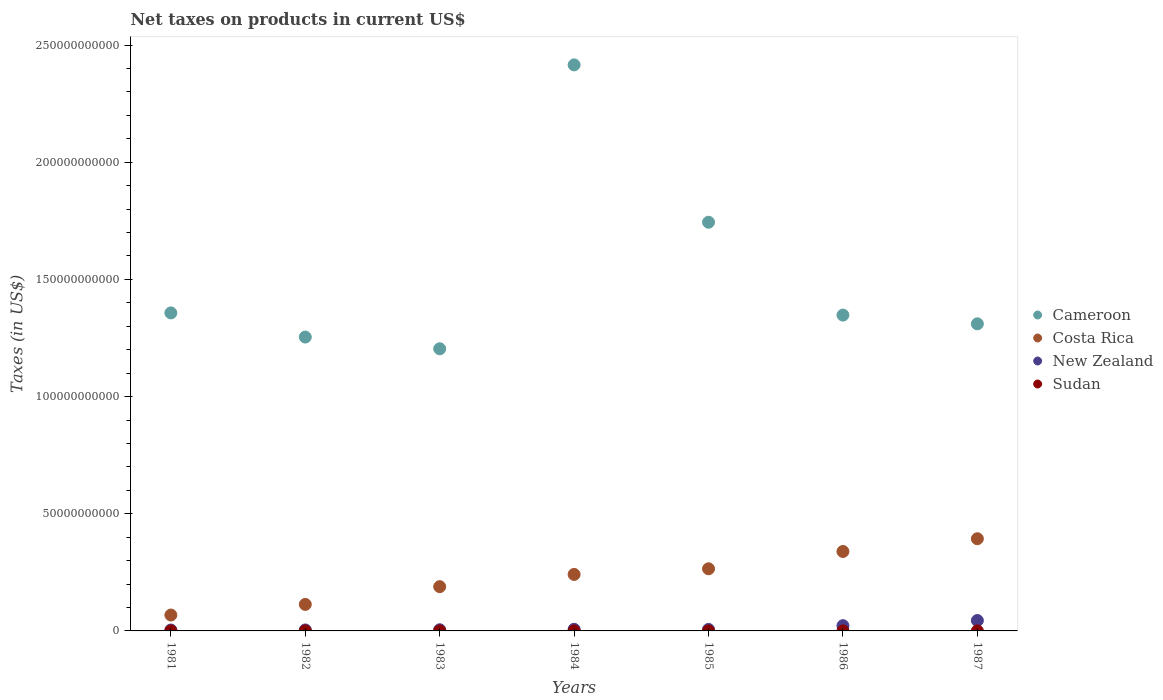Is the number of dotlines equal to the number of legend labels?
Provide a short and direct response. Yes. What is the net taxes on products in New Zealand in 1981?
Your response must be concise. 3.92e+08. Across all years, what is the maximum net taxes on products in Costa Rica?
Offer a terse response. 3.93e+1. Across all years, what is the minimum net taxes on products in Cameroon?
Provide a succinct answer. 1.20e+11. In which year was the net taxes on products in Costa Rica maximum?
Your answer should be very brief. 1987. In which year was the net taxes on products in Costa Rica minimum?
Your answer should be very brief. 1981. What is the total net taxes on products in Cameroon in the graph?
Ensure brevity in your answer.  1.06e+12. What is the difference between the net taxes on products in New Zealand in 1986 and that in 1987?
Your response must be concise. -2.20e+09. What is the difference between the net taxes on products in New Zealand in 1985 and the net taxes on products in Costa Rica in 1981?
Offer a very short reply. -6.14e+09. What is the average net taxes on products in Costa Rica per year?
Provide a short and direct response. 2.30e+1. In the year 1982, what is the difference between the net taxes on products in Costa Rica and net taxes on products in Sudan?
Keep it short and to the point. 1.13e+1. What is the ratio of the net taxes on products in Cameroon in 1981 to that in 1985?
Offer a very short reply. 0.78. Is the net taxes on products in Sudan in 1984 less than that in 1986?
Your answer should be very brief. Yes. What is the difference between the highest and the second highest net taxes on products in New Zealand?
Provide a short and direct response. 2.20e+09. What is the difference between the highest and the lowest net taxes on products in Sudan?
Make the answer very short. 8.36e+05. Is the sum of the net taxes on products in New Zealand in 1981 and 1983 greater than the maximum net taxes on products in Sudan across all years?
Ensure brevity in your answer.  Yes. Is it the case that in every year, the sum of the net taxes on products in Cameroon and net taxes on products in Sudan  is greater than the sum of net taxes on products in New Zealand and net taxes on products in Costa Rica?
Provide a short and direct response. Yes. Is the net taxes on products in Costa Rica strictly greater than the net taxes on products in Sudan over the years?
Provide a short and direct response. Yes. How many dotlines are there?
Your answer should be compact. 4. How many years are there in the graph?
Provide a short and direct response. 7. What is the difference between two consecutive major ticks on the Y-axis?
Offer a very short reply. 5.00e+1. Does the graph contain any zero values?
Your response must be concise. No. Where does the legend appear in the graph?
Give a very brief answer. Center right. What is the title of the graph?
Offer a very short reply. Net taxes on products in current US$. What is the label or title of the Y-axis?
Provide a succinct answer. Taxes (in US$). What is the Taxes (in US$) in Cameroon in 1981?
Give a very brief answer. 1.36e+11. What is the Taxes (in US$) of Costa Rica in 1981?
Your answer should be compact. 6.78e+09. What is the Taxes (in US$) in New Zealand in 1981?
Your answer should be compact. 3.92e+08. What is the Taxes (in US$) of Sudan in 1981?
Your answer should be compact. 4.94e+05. What is the Taxes (in US$) of Cameroon in 1982?
Make the answer very short. 1.25e+11. What is the Taxes (in US$) of Costa Rica in 1982?
Your answer should be very brief. 1.13e+1. What is the Taxes (in US$) in New Zealand in 1982?
Give a very brief answer. 4.13e+08. What is the Taxes (in US$) in Sudan in 1982?
Your answer should be compact. 6.30e+05. What is the Taxes (in US$) in Cameroon in 1983?
Make the answer very short. 1.20e+11. What is the Taxes (in US$) in Costa Rica in 1983?
Ensure brevity in your answer.  1.89e+1. What is the Taxes (in US$) in New Zealand in 1983?
Give a very brief answer. 4.94e+08. What is the Taxes (in US$) of Sudan in 1983?
Offer a terse response. 8.04e+05. What is the Taxes (in US$) in Cameroon in 1984?
Give a very brief answer. 2.42e+11. What is the Taxes (in US$) of Costa Rica in 1984?
Your response must be concise. 2.41e+1. What is the Taxes (in US$) of New Zealand in 1984?
Your response must be concise. 6.85e+08. What is the Taxes (in US$) in Sudan in 1984?
Provide a short and direct response. 9.46e+05. What is the Taxes (in US$) of Cameroon in 1985?
Provide a short and direct response. 1.74e+11. What is the Taxes (in US$) of Costa Rica in 1985?
Your answer should be compact. 2.65e+1. What is the Taxes (in US$) of New Zealand in 1985?
Keep it short and to the point. 6.38e+08. What is the Taxes (in US$) of Sudan in 1985?
Offer a very short reply. 1.15e+06. What is the Taxes (in US$) of Cameroon in 1986?
Provide a succinct answer. 1.35e+11. What is the Taxes (in US$) of Costa Rica in 1986?
Your response must be concise. 3.39e+1. What is the Taxes (in US$) in New Zealand in 1986?
Your response must be concise. 2.24e+09. What is the Taxes (in US$) of Sudan in 1986?
Give a very brief answer. 1.21e+06. What is the Taxes (in US$) in Cameroon in 1987?
Provide a short and direct response. 1.31e+11. What is the Taxes (in US$) of Costa Rica in 1987?
Provide a succinct answer. 3.93e+1. What is the Taxes (in US$) in New Zealand in 1987?
Ensure brevity in your answer.  4.44e+09. What is the Taxes (in US$) in Sudan in 1987?
Ensure brevity in your answer.  1.33e+06. Across all years, what is the maximum Taxes (in US$) in Cameroon?
Your answer should be very brief. 2.42e+11. Across all years, what is the maximum Taxes (in US$) in Costa Rica?
Your response must be concise. 3.93e+1. Across all years, what is the maximum Taxes (in US$) of New Zealand?
Offer a terse response. 4.44e+09. Across all years, what is the maximum Taxes (in US$) in Sudan?
Offer a terse response. 1.33e+06. Across all years, what is the minimum Taxes (in US$) in Cameroon?
Your response must be concise. 1.20e+11. Across all years, what is the minimum Taxes (in US$) in Costa Rica?
Your response must be concise. 6.78e+09. Across all years, what is the minimum Taxes (in US$) of New Zealand?
Provide a short and direct response. 3.92e+08. Across all years, what is the minimum Taxes (in US$) of Sudan?
Offer a terse response. 4.94e+05. What is the total Taxes (in US$) of Cameroon in the graph?
Offer a very short reply. 1.06e+12. What is the total Taxes (in US$) in Costa Rica in the graph?
Keep it short and to the point. 1.61e+11. What is the total Taxes (in US$) of New Zealand in the graph?
Ensure brevity in your answer.  9.30e+09. What is the total Taxes (in US$) of Sudan in the graph?
Make the answer very short. 6.56e+06. What is the difference between the Taxes (in US$) in Cameroon in 1981 and that in 1982?
Provide a succinct answer. 1.03e+1. What is the difference between the Taxes (in US$) of Costa Rica in 1981 and that in 1982?
Your answer should be very brief. -4.53e+09. What is the difference between the Taxes (in US$) of New Zealand in 1981 and that in 1982?
Give a very brief answer. -2.04e+07. What is the difference between the Taxes (in US$) of Sudan in 1981 and that in 1982?
Make the answer very short. -1.37e+05. What is the difference between the Taxes (in US$) in Cameroon in 1981 and that in 1983?
Make the answer very short. 1.53e+1. What is the difference between the Taxes (in US$) of Costa Rica in 1981 and that in 1983?
Offer a very short reply. -1.21e+1. What is the difference between the Taxes (in US$) in New Zealand in 1981 and that in 1983?
Your answer should be compact. -1.01e+08. What is the difference between the Taxes (in US$) of Sudan in 1981 and that in 1983?
Provide a succinct answer. -3.10e+05. What is the difference between the Taxes (in US$) of Cameroon in 1981 and that in 1984?
Your answer should be very brief. -1.06e+11. What is the difference between the Taxes (in US$) of Costa Rica in 1981 and that in 1984?
Your response must be concise. -1.73e+1. What is the difference between the Taxes (in US$) of New Zealand in 1981 and that in 1984?
Your response must be concise. -2.93e+08. What is the difference between the Taxes (in US$) of Sudan in 1981 and that in 1984?
Offer a very short reply. -4.53e+05. What is the difference between the Taxes (in US$) of Cameroon in 1981 and that in 1985?
Offer a very short reply. -3.87e+1. What is the difference between the Taxes (in US$) in Costa Rica in 1981 and that in 1985?
Your answer should be very brief. -1.97e+1. What is the difference between the Taxes (in US$) in New Zealand in 1981 and that in 1985?
Give a very brief answer. -2.45e+08. What is the difference between the Taxes (in US$) of Sudan in 1981 and that in 1985?
Your response must be concise. -6.57e+05. What is the difference between the Taxes (in US$) in Cameroon in 1981 and that in 1986?
Ensure brevity in your answer.  9.34e+08. What is the difference between the Taxes (in US$) of Costa Rica in 1981 and that in 1986?
Your answer should be compact. -2.71e+1. What is the difference between the Taxes (in US$) in New Zealand in 1981 and that in 1986?
Keep it short and to the point. -1.85e+09. What is the difference between the Taxes (in US$) of Sudan in 1981 and that in 1986?
Give a very brief answer. -7.13e+05. What is the difference between the Taxes (in US$) of Cameroon in 1981 and that in 1987?
Give a very brief answer. 4.66e+09. What is the difference between the Taxes (in US$) in Costa Rica in 1981 and that in 1987?
Ensure brevity in your answer.  -3.26e+1. What is the difference between the Taxes (in US$) in New Zealand in 1981 and that in 1987?
Provide a short and direct response. -4.05e+09. What is the difference between the Taxes (in US$) in Sudan in 1981 and that in 1987?
Offer a terse response. -8.36e+05. What is the difference between the Taxes (in US$) in Cameroon in 1982 and that in 1983?
Your answer should be compact. 5.00e+09. What is the difference between the Taxes (in US$) of Costa Rica in 1982 and that in 1983?
Provide a succinct answer. -7.57e+09. What is the difference between the Taxes (in US$) of New Zealand in 1982 and that in 1983?
Keep it short and to the point. -8.09e+07. What is the difference between the Taxes (in US$) of Sudan in 1982 and that in 1983?
Give a very brief answer. -1.74e+05. What is the difference between the Taxes (in US$) of Cameroon in 1982 and that in 1984?
Your response must be concise. -1.16e+11. What is the difference between the Taxes (in US$) of Costa Rica in 1982 and that in 1984?
Your answer should be compact. -1.28e+1. What is the difference between the Taxes (in US$) of New Zealand in 1982 and that in 1984?
Offer a very short reply. -2.72e+08. What is the difference between the Taxes (in US$) in Sudan in 1982 and that in 1984?
Provide a short and direct response. -3.16e+05. What is the difference between the Taxes (in US$) of Cameroon in 1982 and that in 1985?
Keep it short and to the point. -4.90e+1. What is the difference between the Taxes (in US$) of Costa Rica in 1982 and that in 1985?
Provide a succinct answer. -1.52e+1. What is the difference between the Taxes (in US$) in New Zealand in 1982 and that in 1985?
Offer a very short reply. -2.25e+08. What is the difference between the Taxes (in US$) of Sudan in 1982 and that in 1985?
Offer a very short reply. -5.20e+05. What is the difference between the Taxes (in US$) in Cameroon in 1982 and that in 1986?
Provide a short and direct response. -9.38e+09. What is the difference between the Taxes (in US$) of Costa Rica in 1982 and that in 1986?
Keep it short and to the point. -2.26e+1. What is the difference between the Taxes (in US$) in New Zealand in 1982 and that in 1986?
Offer a very short reply. -1.83e+09. What is the difference between the Taxes (in US$) in Sudan in 1982 and that in 1986?
Make the answer very short. -5.76e+05. What is the difference between the Taxes (in US$) of Cameroon in 1982 and that in 1987?
Make the answer very short. -5.65e+09. What is the difference between the Taxes (in US$) in Costa Rica in 1982 and that in 1987?
Ensure brevity in your answer.  -2.80e+1. What is the difference between the Taxes (in US$) of New Zealand in 1982 and that in 1987?
Keep it short and to the point. -4.03e+09. What is the difference between the Taxes (in US$) in Sudan in 1982 and that in 1987?
Your answer should be compact. -6.98e+05. What is the difference between the Taxes (in US$) of Cameroon in 1983 and that in 1984?
Your answer should be compact. -1.21e+11. What is the difference between the Taxes (in US$) of Costa Rica in 1983 and that in 1984?
Offer a terse response. -5.22e+09. What is the difference between the Taxes (in US$) of New Zealand in 1983 and that in 1984?
Offer a very short reply. -1.91e+08. What is the difference between the Taxes (in US$) of Sudan in 1983 and that in 1984?
Give a very brief answer. -1.42e+05. What is the difference between the Taxes (in US$) of Cameroon in 1983 and that in 1985?
Give a very brief answer. -5.40e+1. What is the difference between the Taxes (in US$) of Costa Rica in 1983 and that in 1985?
Your response must be concise. -7.63e+09. What is the difference between the Taxes (in US$) of New Zealand in 1983 and that in 1985?
Provide a short and direct response. -1.44e+08. What is the difference between the Taxes (in US$) in Sudan in 1983 and that in 1985?
Keep it short and to the point. -3.46e+05. What is the difference between the Taxes (in US$) of Cameroon in 1983 and that in 1986?
Make the answer very short. -1.44e+1. What is the difference between the Taxes (in US$) of Costa Rica in 1983 and that in 1986?
Give a very brief answer. -1.50e+1. What is the difference between the Taxes (in US$) in New Zealand in 1983 and that in 1986?
Give a very brief answer. -1.75e+09. What is the difference between the Taxes (in US$) in Sudan in 1983 and that in 1986?
Your answer should be very brief. -4.02e+05. What is the difference between the Taxes (in US$) of Cameroon in 1983 and that in 1987?
Give a very brief answer. -1.06e+1. What is the difference between the Taxes (in US$) of Costa Rica in 1983 and that in 1987?
Keep it short and to the point. -2.04e+1. What is the difference between the Taxes (in US$) of New Zealand in 1983 and that in 1987?
Your answer should be compact. -3.94e+09. What is the difference between the Taxes (in US$) in Sudan in 1983 and that in 1987?
Provide a succinct answer. -5.25e+05. What is the difference between the Taxes (in US$) in Cameroon in 1984 and that in 1985?
Make the answer very short. 6.72e+1. What is the difference between the Taxes (in US$) of Costa Rica in 1984 and that in 1985?
Your answer should be compact. -2.41e+09. What is the difference between the Taxes (in US$) of New Zealand in 1984 and that in 1985?
Give a very brief answer. 4.74e+07. What is the difference between the Taxes (in US$) of Sudan in 1984 and that in 1985?
Your answer should be very brief. -2.04e+05. What is the difference between the Taxes (in US$) of Cameroon in 1984 and that in 1986?
Offer a terse response. 1.07e+11. What is the difference between the Taxes (in US$) of Costa Rica in 1984 and that in 1986?
Make the answer very short. -9.80e+09. What is the difference between the Taxes (in US$) of New Zealand in 1984 and that in 1986?
Keep it short and to the point. -1.55e+09. What is the difference between the Taxes (in US$) in Cameroon in 1984 and that in 1987?
Keep it short and to the point. 1.11e+11. What is the difference between the Taxes (in US$) in Costa Rica in 1984 and that in 1987?
Offer a very short reply. -1.52e+1. What is the difference between the Taxes (in US$) in New Zealand in 1984 and that in 1987?
Give a very brief answer. -3.75e+09. What is the difference between the Taxes (in US$) in Sudan in 1984 and that in 1987?
Your response must be concise. -3.82e+05. What is the difference between the Taxes (in US$) of Cameroon in 1985 and that in 1986?
Make the answer very short. 3.96e+1. What is the difference between the Taxes (in US$) in Costa Rica in 1985 and that in 1986?
Your response must be concise. -7.39e+09. What is the difference between the Taxes (in US$) in New Zealand in 1985 and that in 1986?
Your answer should be compact. -1.60e+09. What is the difference between the Taxes (in US$) of Sudan in 1985 and that in 1986?
Offer a terse response. -5.60e+04. What is the difference between the Taxes (in US$) of Cameroon in 1985 and that in 1987?
Your response must be concise. 4.34e+1. What is the difference between the Taxes (in US$) in Costa Rica in 1985 and that in 1987?
Your answer should be very brief. -1.28e+1. What is the difference between the Taxes (in US$) in New Zealand in 1985 and that in 1987?
Offer a terse response. -3.80e+09. What is the difference between the Taxes (in US$) of Sudan in 1985 and that in 1987?
Give a very brief answer. -1.78e+05. What is the difference between the Taxes (in US$) of Cameroon in 1986 and that in 1987?
Give a very brief answer. 3.73e+09. What is the difference between the Taxes (in US$) of Costa Rica in 1986 and that in 1987?
Your answer should be compact. -5.44e+09. What is the difference between the Taxes (in US$) of New Zealand in 1986 and that in 1987?
Your answer should be compact. -2.20e+09. What is the difference between the Taxes (in US$) in Sudan in 1986 and that in 1987?
Offer a terse response. -1.22e+05. What is the difference between the Taxes (in US$) of Cameroon in 1981 and the Taxes (in US$) of Costa Rica in 1982?
Your answer should be compact. 1.24e+11. What is the difference between the Taxes (in US$) of Cameroon in 1981 and the Taxes (in US$) of New Zealand in 1982?
Provide a short and direct response. 1.35e+11. What is the difference between the Taxes (in US$) of Cameroon in 1981 and the Taxes (in US$) of Sudan in 1982?
Offer a terse response. 1.36e+11. What is the difference between the Taxes (in US$) of Costa Rica in 1981 and the Taxes (in US$) of New Zealand in 1982?
Offer a terse response. 6.37e+09. What is the difference between the Taxes (in US$) of Costa Rica in 1981 and the Taxes (in US$) of Sudan in 1982?
Offer a very short reply. 6.78e+09. What is the difference between the Taxes (in US$) of New Zealand in 1981 and the Taxes (in US$) of Sudan in 1982?
Your response must be concise. 3.92e+08. What is the difference between the Taxes (in US$) in Cameroon in 1981 and the Taxes (in US$) in Costa Rica in 1983?
Your answer should be very brief. 1.17e+11. What is the difference between the Taxes (in US$) in Cameroon in 1981 and the Taxes (in US$) in New Zealand in 1983?
Your answer should be compact. 1.35e+11. What is the difference between the Taxes (in US$) in Cameroon in 1981 and the Taxes (in US$) in Sudan in 1983?
Provide a short and direct response. 1.36e+11. What is the difference between the Taxes (in US$) of Costa Rica in 1981 and the Taxes (in US$) of New Zealand in 1983?
Your answer should be compact. 6.29e+09. What is the difference between the Taxes (in US$) in Costa Rica in 1981 and the Taxes (in US$) in Sudan in 1983?
Ensure brevity in your answer.  6.78e+09. What is the difference between the Taxes (in US$) in New Zealand in 1981 and the Taxes (in US$) in Sudan in 1983?
Ensure brevity in your answer.  3.92e+08. What is the difference between the Taxes (in US$) of Cameroon in 1981 and the Taxes (in US$) of Costa Rica in 1984?
Offer a terse response. 1.12e+11. What is the difference between the Taxes (in US$) of Cameroon in 1981 and the Taxes (in US$) of New Zealand in 1984?
Offer a very short reply. 1.35e+11. What is the difference between the Taxes (in US$) in Cameroon in 1981 and the Taxes (in US$) in Sudan in 1984?
Provide a succinct answer. 1.36e+11. What is the difference between the Taxes (in US$) of Costa Rica in 1981 and the Taxes (in US$) of New Zealand in 1984?
Provide a short and direct response. 6.10e+09. What is the difference between the Taxes (in US$) of Costa Rica in 1981 and the Taxes (in US$) of Sudan in 1984?
Your response must be concise. 6.78e+09. What is the difference between the Taxes (in US$) of New Zealand in 1981 and the Taxes (in US$) of Sudan in 1984?
Your answer should be compact. 3.91e+08. What is the difference between the Taxes (in US$) of Cameroon in 1981 and the Taxes (in US$) of Costa Rica in 1985?
Offer a very short reply. 1.09e+11. What is the difference between the Taxes (in US$) of Cameroon in 1981 and the Taxes (in US$) of New Zealand in 1985?
Give a very brief answer. 1.35e+11. What is the difference between the Taxes (in US$) of Cameroon in 1981 and the Taxes (in US$) of Sudan in 1985?
Give a very brief answer. 1.36e+11. What is the difference between the Taxes (in US$) of Costa Rica in 1981 and the Taxes (in US$) of New Zealand in 1985?
Offer a terse response. 6.14e+09. What is the difference between the Taxes (in US$) in Costa Rica in 1981 and the Taxes (in US$) in Sudan in 1985?
Offer a terse response. 6.78e+09. What is the difference between the Taxes (in US$) of New Zealand in 1981 and the Taxes (in US$) of Sudan in 1985?
Ensure brevity in your answer.  3.91e+08. What is the difference between the Taxes (in US$) in Cameroon in 1981 and the Taxes (in US$) in Costa Rica in 1986?
Offer a very short reply. 1.02e+11. What is the difference between the Taxes (in US$) of Cameroon in 1981 and the Taxes (in US$) of New Zealand in 1986?
Make the answer very short. 1.33e+11. What is the difference between the Taxes (in US$) of Cameroon in 1981 and the Taxes (in US$) of Sudan in 1986?
Your answer should be very brief. 1.36e+11. What is the difference between the Taxes (in US$) in Costa Rica in 1981 and the Taxes (in US$) in New Zealand in 1986?
Your answer should be compact. 4.54e+09. What is the difference between the Taxes (in US$) of Costa Rica in 1981 and the Taxes (in US$) of Sudan in 1986?
Keep it short and to the point. 6.78e+09. What is the difference between the Taxes (in US$) of New Zealand in 1981 and the Taxes (in US$) of Sudan in 1986?
Make the answer very short. 3.91e+08. What is the difference between the Taxes (in US$) of Cameroon in 1981 and the Taxes (in US$) of Costa Rica in 1987?
Your answer should be very brief. 9.64e+1. What is the difference between the Taxes (in US$) in Cameroon in 1981 and the Taxes (in US$) in New Zealand in 1987?
Give a very brief answer. 1.31e+11. What is the difference between the Taxes (in US$) in Cameroon in 1981 and the Taxes (in US$) in Sudan in 1987?
Your answer should be compact. 1.36e+11. What is the difference between the Taxes (in US$) in Costa Rica in 1981 and the Taxes (in US$) in New Zealand in 1987?
Keep it short and to the point. 2.34e+09. What is the difference between the Taxes (in US$) in Costa Rica in 1981 and the Taxes (in US$) in Sudan in 1987?
Your response must be concise. 6.78e+09. What is the difference between the Taxes (in US$) of New Zealand in 1981 and the Taxes (in US$) of Sudan in 1987?
Offer a very short reply. 3.91e+08. What is the difference between the Taxes (in US$) of Cameroon in 1982 and the Taxes (in US$) of Costa Rica in 1983?
Give a very brief answer. 1.07e+11. What is the difference between the Taxes (in US$) of Cameroon in 1982 and the Taxes (in US$) of New Zealand in 1983?
Provide a short and direct response. 1.25e+11. What is the difference between the Taxes (in US$) in Cameroon in 1982 and the Taxes (in US$) in Sudan in 1983?
Offer a very short reply. 1.25e+11. What is the difference between the Taxes (in US$) in Costa Rica in 1982 and the Taxes (in US$) in New Zealand in 1983?
Provide a short and direct response. 1.08e+1. What is the difference between the Taxes (in US$) of Costa Rica in 1982 and the Taxes (in US$) of Sudan in 1983?
Keep it short and to the point. 1.13e+1. What is the difference between the Taxes (in US$) in New Zealand in 1982 and the Taxes (in US$) in Sudan in 1983?
Offer a very short reply. 4.12e+08. What is the difference between the Taxes (in US$) of Cameroon in 1982 and the Taxes (in US$) of Costa Rica in 1984?
Give a very brief answer. 1.01e+11. What is the difference between the Taxes (in US$) in Cameroon in 1982 and the Taxes (in US$) in New Zealand in 1984?
Provide a short and direct response. 1.25e+11. What is the difference between the Taxes (in US$) in Cameroon in 1982 and the Taxes (in US$) in Sudan in 1984?
Ensure brevity in your answer.  1.25e+11. What is the difference between the Taxes (in US$) of Costa Rica in 1982 and the Taxes (in US$) of New Zealand in 1984?
Your response must be concise. 1.06e+1. What is the difference between the Taxes (in US$) of Costa Rica in 1982 and the Taxes (in US$) of Sudan in 1984?
Give a very brief answer. 1.13e+1. What is the difference between the Taxes (in US$) of New Zealand in 1982 and the Taxes (in US$) of Sudan in 1984?
Provide a succinct answer. 4.12e+08. What is the difference between the Taxes (in US$) of Cameroon in 1982 and the Taxes (in US$) of Costa Rica in 1985?
Your answer should be very brief. 9.89e+1. What is the difference between the Taxes (in US$) in Cameroon in 1982 and the Taxes (in US$) in New Zealand in 1985?
Ensure brevity in your answer.  1.25e+11. What is the difference between the Taxes (in US$) in Cameroon in 1982 and the Taxes (in US$) in Sudan in 1985?
Keep it short and to the point. 1.25e+11. What is the difference between the Taxes (in US$) of Costa Rica in 1982 and the Taxes (in US$) of New Zealand in 1985?
Offer a terse response. 1.07e+1. What is the difference between the Taxes (in US$) in Costa Rica in 1982 and the Taxes (in US$) in Sudan in 1985?
Offer a terse response. 1.13e+1. What is the difference between the Taxes (in US$) in New Zealand in 1982 and the Taxes (in US$) in Sudan in 1985?
Provide a succinct answer. 4.12e+08. What is the difference between the Taxes (in US$) in Cameroon in 1982 and the Taxes (in US$) in Costa Rica in 1986?
Make the answer very short. 9.15e+1. What is the difference between the Taxes (in US$) of Cameroon in 1982 and the Taxes (in US$) of New Zealand in 1986?
Your answer should be compact. 1.23e+11. What is the difference between the Taxes (in US$) in Cameroon in 1982 and the Taxes (in US$) in Sudan in 1986?
Make the answer very short. 1.25e+11. What is the difference between the Taxes (in US$) in Costa Rica in 1982 and the Taxes (in US$) in New Zealand in 1986?
Ensure brevity in your answer.  9.08e+09. What is the difference between the Taxes (in US$) of Costa Rica in 1982 and the Taxes (in US$) of Sudan in 1986?
Keep it short and to the point. 1.13e+1. What is the difference between the Taxes (in US$) in New Zealand in 1982 and the Taxes (in US$) in Sudan in 1986?
Your response must be concise. 4.12e+08. What is the difference between the Taxes (in US$) of Cameroon in 1982 and the Taxes (in US$) of Costa Rica in 1987?
Your answer should be very brief. 8.61e+1. What is the difference between the Taxes (in US$) of Cameroon in 1982 and the Taxes (in US$) of New Zealand in 1987?
Ensure brevity in your answer.  1.21e+11. What is the difference between the Taxes (in US$) of Cameroon in 1982 and the Taxes (in US$) of Sudan in 1987?
Give a very brief answer. 1.25e+11. What is the difference between the Taxes (in US$) in Costa Rica in 1982 and the Taxes (in US$) in New Zealand in 1987?
Your answer should be very brief. 6.88e+09. What is the difference between the Taxes (in US$) in Costa Rica in 1982 and the Taxes (in US$) in Sudan in 1987?
Provide a short and direct response. 1.13e+1. What is the difference between the Taxes (in US$) of New Zealand in 1982 and the Taxes (in US$) of Sudan in 1987?
Provide a succinct answer. 4.11e+08. What is the difference between the Taxes (in US$) in Cameroon in 1983 and the Taxes (in US$) in Costa Rica in 1984?
Offer a very short reply. 9.63e+1. What is the difference between the Taxes (in US$) of Cameroon in 1983 and the Taxes (in US$) of New Zealand in 1984?
Offer a terse response. 1.20e+11. What is the difference between the Taxes (in US$) in Cameroon in 1983 and the Taxes (in US$) in Sudan in 1984?
Your answer should be compact. 1.20e+11. What is the difference between the Taxes (in US$) of Costa Rica in 1983 and the Taxes (in US$) of New Zealand in 1984?
Offer a terse response. 1.82e+1. What is the difference between the Taxes (in US$) of Costa Rica in 1983 and the Taxes (in US$) of Sudan in 1984?
Offer a very short reply. 1.89e+1. What is the difference between the Taxes (in US$) in New Zealand in 1983 and the Taxes (in US$) in Sudan in 1984?
Your answer should be very brief. 4.93e+08. What is the difference between the Taxes (in US$) of Cameroon in 1983 and the Taxes (in US$) of Costa Rica in 1985?
Offer a very short reply. 9.39e+1. What is the difference between the Taxes (in US$) in Cameroon in 1983 and the Taxes (in US$) in New Zealand in 1985?
Ensure brevity in your answer.  1.20e+11. What is the difference between the Taxes (in US$) of Cameroon in 1983 and the Taxes (in US$) of Sudan in 1985?
Your response must be concise. 1.20e+11. What is the difference between the Taxes (in US$) of Costa Rica in 1983 and the Taxes (in US$) of New Zealand in 1985?
Your response must be concise. 1.83e+1. What is the difference between the Taxes (in US$) in Costa Rica in 1983 and the Taxes (in US$) in Sudan in 1985?
Keep it short and to the point. 1.89e+1. What is the difference between the Taxes (in US$) in New Zealand in 1983 and the Taxes (in US$) in Sudan in 1985?
Offer a terse response. 4.92e+08. What is the difference between the Taxes (in US$) in Cameroon in 1983 and the Taxes (in US$) in Costa Rica in 1986?
Ensure brevity in your answer.  8.65e+1. What is the difference between the Taxes (in US$) in Cameroon in 1983 and the Taxes (in US$) in New Zealand in 1986?
Offer a terse response. 1.18e+11. What is the difference between the Taxes (in US$) in Cameroon in 1983 and the Taxes (in US$) in Sudan in 1986?
Ensure brevity in your answer.  1.20e+11. What is the difference between the Taxes (in US$) in Costa Rica in 1983 and the Taxes (in US$) in New Zealand in 1986?
Give a very brief answer. 1.67e+1. What is the difference between the Taxes (in US$) in Costa Rica in 1983 and the Taxes (in US$) in Sudan in 1986?
Ensure brevity in your answer.  1.89e+1. What is the difference between the Taxes (in US$) in New Zealand in 1983 and the Taxes (in US$) in Sudan in 1986?
Keep it short and to the point. 4.92e+08. What is the difference between the Taxes (in US$) in Cameroon in 1983 and the Taxes (in US$) in Costa Rica in 1987?
Ensure brevity in your answer.  8.11e+1. What is the difference between the Taxes (in US$) in Cameroon in 1983 and the Taxes (in US$) in New Zealand in 1987?
Provide a short and direct response. 1.16e+11. What is the difference between the Taxes (in US$) in Cameroon in 1983 and the Taxes (in US$) in Sudan in 1987?
Your response must be concise. 1.20e+11. What is the difference between the Taxes (in US$) in Costa Rica in 1983 and the Taxes (in US$) in New Zealand in 1987?
Provide a short and direct response. 1.45e+1. What is the difference between the Taxes (in US$) of Costa Rica in 1983 and the Taxes (in US$) of Sudan in 1987?
Your answer should be compact. 1.89e+1. What is the difference between the Taxes (in US$) in New Zealand in 1983 and the Taxes (in US$) in Sudan in 1987?
Your answer should be compact. 4.92e+08. What is the difference between the Taxes (in US$) of Cameroon in 1984 and the Taxes (in US$) of Costa Rica in 1985?
Provide a short and direct response. 2.15e+11. What is the difference between the Taxes (in US$) in Cameroon in 1984 and the Taxes (in US$) in New Zealand in 1985?
Provide a succinct answer. 2.41e+11. What is the difference between the Taxes (in US$) of Cameroon in 1984 and the Taxes (in US$) of Sudan in 1985?
Provide a short and direct response. 2.42e+11. What is the difference between the Taxes (in US$) in Costa Rica in 1984 and the Taxes (in US$) in New Zealand in 1985?
Your answer should be very brief. 2.35e+1. What is the difference between the Taxes (in US$) of Costa Rica in 1984 and the Taxes (in US$) of Sudan in 1985?
Your answer should be very brief. 2.41e+1. What is the difference between the Taxes (in US$) in New Zealand in 1984 and the Taxes (in US$) in Sudan in 1985?
Offer a terse response. 6.84e+08. What is the difference between the Taxes (in US$) in Cameroon in 1984 and the Taxes (in US$) in Costa Rica in 1986?
Give a very brief answer. 2.08e+11. What is the difference between the Taxes (in US$) of Cameroon in 1984 and the Taxes (in US$) of New Zealand in 1986?
Provide a short and direct response. 2.39e+11. What is the difference between the Taxes (in US$) in Cameroon in 1984 and the Taxes (in US$) in Sudan in 1986?
Your answer should be compact. 2.42e+11. What is the difference between the Taxes (in US$) of Costa Rica in 1984 and the Taxes (in US$) of New Zealand in 1986?
Give a very brief answer. 2.19e+1. What is the difference between the Taxes (in US$) in Costa Rica in 1984 and the Taxes (in US$) in Sudan in 1986?
Offer a very short reply. 2.41e+1. What is the difference between the Taxes (in US$) of New Zealand in 1984 and the Taxes (in US$) of Sudan in 1986?
Provide a succinct answer. 6.84e+08. What is the difference between the Taxes (in US$) of Cameroon in 1984 and the Taxes (in US$) of Costa Rica in 1987?
Make the answer very short. 2.02e+11. What is the difference between the Taxes (in US$) in Cameroon in 1984 and the Taxes (in US$) in New Zealand in 1987?
Keep it short and to the point. 2.37e+11. What is the difference between the Taxes (in US$) in Cameroon in 1984 and the Taxes (in US$) in Sudan in 1987?
Give a very brief answer. 2.42e+11. What is the difference between the Taxes (in US$) of Costa Rica in 1984 and the Taxes (in US$) of New Zealand in 1987?
Give a very brief answer. 1.97e+1. What is the difference between the Taxes (in US$) of Costa Rica in 1984 and the Taxes (in US$) of Sudan in 1987?
Your response must be concise. 2.41e+1. What is the difference between the Taxes (in US$) of New Zealand in 1984 and the Taxes (in US$) of Sudan in 1987?
Offer a very short reply. 6.84e+08. What is the difference between the Taxes (in US$) of Cameroon in 1985 and the Taxes (in US$) of Costa Rica in 1986?
Your response must be concise. 1.40e+11. What is the difference between the Taxes (in US$) in Cameroon in 1985 and the Taxes (in US$) in New Zealand in 1986?
Make the answer very short. 1.72e+11. What is the difference between the Taxes (in US$) of Cameroon in 1985 and the Taxes (in US$) of Sudan in 1986?
Your answer should be compact. 1.74e+11. What is the difference between the Taxes (in US$) of Costa Rica in 1985 and the Taxes (in US$) of New Zealand in 1986?
Offer a very short reply. 2.43e+1. What is the difference between the Taxes (in US$) in Costa Rica in 1985 and the Taxes (in US$) in Sudan in 1986?
Provide a succinct answer. 2.65e+1. What is the difference between the Taxes (in US$) of New Zealand in 1985 and the Taxes (in US$) of Sudan in 1986?
Your answer should be compact. 6.36e+08. What is the difference between the Taxes (in US$) of Cameroon in 1985 and the Taxes (in US$) of Costa Rica in 1987?
Keep it short and to the point. 1.35e+11. What is the difference between the Taxes (in US$) in Cameroon in 1985 and the Taxes (in US$) in New Zealand in 1987?
Keep it short and to the point. 1.70e+11. What is the difference between the Taxes (in US$) in Cameroon in 1985 and the Taxes (in US$) in Sudan in 1987?
Make the answer very short. 1.74e+11. What is the difference between the Taxes (in US$) of Costa Rica in 1985 and the Taxes (in US$) of New Zealand in 1987?
Ensure brevity in your answer.  2.21e+1. What is the difference between the Taxes (in US$) of Costa Rica in 1985 and the Taxes (in US$) of Sudan in 1987?
Give a very brief answer. 2.65e+1. What is the difference between the Taxes (in US$) of New Zealand in 1985 and the Taxes (in US$) of Sudan in 1987?
Provide a succinct answer. 6.36e+08. What is the difference between the Taxes (in US$) of Cameroon in 1986 and the Taxes (in US$) of Costa Rica in 1987?
Offer a terse response. 9.54e+1. What is the difference between the Taxes (in US$) in Cameroon in 1986 and the Taxes (in US$) in New Zealand in 1987?
Give a very brief answer. 1.30e+11. What is the difference between the Taxes (in US$) of Cameroon in 1986 and the Taxes (in US$) of Sudan in 1987?
Offer a terse response. 1.35e+11. What is the difference between the Taxes (in US$) of Costa Rica in 1986 and the Taxes (in US$) of New Zealand in 1987?
Your answer should be very brief. 2.95e+1. What is the difference between the Taxes (in US$) of Costa Rica in 1986 and the Taxes (in US$) of Sudan in 1987?
Give a very brief answer. 3.39e+1. What is the difference between the Taxes (in US$) in New Zealand in 1986 and the Taxes (in US$) in Sudan in 1987?
Make the answer very short. 2.24e+09. What is the average Taxes (in US$) in Cameroon per year?
Offer a terse response. 1.52e+11. What is the average Taxes (in US$) of Costa Rica per year?
Your answer should be very brief. 2.30e+1. What is the average Taxes (in US$) of New Zealand per year?
Your answer should be very brief. 1.33e+09. What is the average Taxes (in US$) of Sudan per year?
Your response must be concise. 9.37e+05. In the year 1981, what is the difference between the Taxes (in US$) of Cameroon and Taxes (in US$) of Costa Rica?
Give a very brief answer. 1.29e+11. In the year 1981, what is the difference between the Taxes (in US$) of Cameroon and Taxes (in US$) of New Zealand?
Offer a very short reply. 1.35e+11. In the year 1981, what is the difference between the Taxes (in US$) in Cameroon and Taxes (in US$) in Sudan?
Provide a succinct answer. 1.36e+11. In the year 1981, what is the difference between the Taxes (in US$) in Costa Rica and Taxes (in US$) in New Zealand?
Your answer should be very brief. 6.39e+09. In the year 1981, what is the difference between the Taxes (in US$) in Costa Rica and Taxes (in US$) in Sudan?
Keep it short and to the point. 6.78e+09. In the year 1981, what is the difference between the Taxes (in US$) of New Zealand and Taxes (in US$) of Sudan?
Ensure brevity in your answer.  3.92e+08. In the year 1982, what is the difference between the Taxes (in US$) in Cameroon and Taxes (in US$) in Costa Rica?
Give a very brief answer. 1.14e+11. In the year 1982, what is the difference between the Taxes (in US$) in Cameroon and Taxes (in US$) in New Zealand?
Your response must be concise. 1.25e+11. In the year 1982, what is the difference between the Taxes (in US$) of Cameroon and Taxes (in US$) of Sudan?
Ensure brevity in your answer.  1.25e+11. In the year 1982, what is the difference between the Taxes (in US$) in Costa Rica and Taxes (in US$) in New Zealand?
Keep it short and to the point. 1.09e+1. In the year 1982, what is the difference between the Taxes (in US$) of Costa Rica and Taxes (in US$) of Sudan?
Your answer should be compact. 1.13e+1. In the year 1982, what is the difference between the Taxes (in US$) of New Zealand and Taxes (in US$) of Sudan?
Keep it short and to the point. 4.12e+08. In the year 1983, what is the difference between the Taxes (in US$) in Cameroon and Taxes (in US$) in Costa Rica?
Your answer should be very brief. 1.02e+11. In the year 1983, what is the difference between the Taxes (in US$) of Cameroon and Taxes (in US$) of New Zealand?
Keep it short and to the point. 1.20e+11. In the year 1983, what is the difference between the Taxes (in US$) in Cameroon and Taxes (in US$) in Sudan?
Ensure brevity in your answer.  1.20e+11. In the year 1983, what is the difference between the Taxes (in US$) in Costa Rica and Taxes (in US$) in New Zealand?
Keep it short and to the point. 1.84e+1. In the year 1983, what is the difference between the Taxes (in US$) in Costa Rica and Taxes (in US$) in Sudan?
Your answer should be very brief. 1.89e+1. In the year 1983, what is the difference between the Taxes (in US$) of New Zealand and Taxes (in US$) of Sudan?
Your response must be concise. 4.93e+08. In the year 1984, what is the difference between the Taxes (in US$) in Cameroon and Taxes (in US$) in Costa Rica?
Keep it short and to the point. 2.17e+11. In the year 1984, what is the difference between the Taxes (in US$) of Cameroon and Taxes (in US$) of New Zealand?
Keep it short and to the point. 2.41e+11. In the year 1984, what is the difference between the Taxes (in US$) of Cameroon and Taxes (in US$) of Sudan?
Give a very brief answer. 2.42e+11. In the year 1984, what is the difference between the Taxes (in US$) of Costa Rica and Taxes (in US$) of New Zealand?
Provide a short and direct response. 2.34e+1. In the year 1984, what is the difference between the Taxes (in US$) in Costa Rica and Taxes (in US$) in Sudan?
Make the answer very short. 2.41e+1. In the year 1984, what is the difference between the Taxes (in US$) of New Zealand and Taxes (in US$) of Sudan?
Provide a short and direct response. 6.84e+08. In the year 1985, what is the difference between the Taxes (in US$) of Cameroon and Taxes (in US$) of Costa Rica?
Your answer should be compact. 1.48e+11. In the year 1985, what is the difference between the Taxes (in US$) of Cameroon and Taxes (in US$) of New Zealand?
Make the answer very short. 1.74e+11. In the year 1985, what is the difference between the Taxes (in US$) in Cameroon and Taxes (in US$) in Sudan?
Give a very brief answer. 1.74e+11. In the year 1985, what is the difference between the Taxes (in US$) of Costa Rica and Taxes (in US$) of New Zealand?
Give a very brief answer. 2.59e+1. In the year 1985, what is the difference between the Taxes (in US$) of Costa Rica and Taxes (in US$) of Sudan?
Your response must be concise. 2.65e+1. In the year 1985, what is the difference between the Taxes (in US$) of New Zealand and Taxes (in US$) of Sudan?
Keep it short and to the point. 6.36e+08. In the year 1986, what is the difference between the Taxes (in US$) in Cameroon and Taxes (in US$) in Costa Rica?
Provide a short and direct response. 1.01e+11. In the year 1986, what is the difference between the Taxes (in US$) in Cameroon and Taxes (in US$) in New Zealand?
Give a very brief answer. 1.33e+11. In the year 1986, what is the difference between the Taxes (in US$) of Cameroon and Taxes (in US$) of Sudan?
Keep it short and to the point. 1.35e+11. In the year 1986, what is the difference between the Taxes (in US$) in Costa Rica and Taxes (in US$) in New Zealand?
Keep it short and to the point. 3.17e+1. In the year 1986, what is the difference between the Taxes (in US$) in Costa Rica and Taxes (in US$) in Sudan?
Provide a succinct answer. 3.39e+1. In the year 1986, what is the difference between the Taxes (in US$) in New Zealand and Taxes (in US$) in Sudan?
Ensure brevity in your answer.  2.24e+09. In the year 1987, what is the difference between the Taxes (in US$) in Cameroon and Taxes (in US$) in Costa Rica?
Give a very brief answer. 9.17e+1. In the year 1987, what is the difference between the Taxes (in US$) in Cameroon and Taxes (in US$) in New Zealand?
Your answer should be very brief. 1.27e+11. In the year 1987, what is the difference between the Taxes (in US$) in Cameroon and Taxes (in US$) in Sudan?
Your response must be concise. 1.31e+11. In the year 1987, what is the difference between the Taxes (in US$) in Costa Rica and Taxes (in US$) in New Zealand?
Give a very brief answer. 3.49e+1. In the year 1987, what is the difference between the Taxes (in US$) of Costa Rica and Taxes (in US$) of Sudan?
Offer a terse response. 3.93e+1. In the year 1987, what is the difference between the Taxes (in US$) in New Zealand and Taxes (in US$) in Sudan?
Offer a very short reply. 4.44e+09. What is the ratio of the Taxes (in US$) in Cameroon in 1981 to that in 1982?
Your answer should be compact. 1.08. What is the ratio of the Taxes (in US$) in Costa Rica in 1981 to that in 1982?
Give a very brief answer. 0.6. What is the ratio of the Taxes (in US$) of New Zealand in 1981 to that in 1982?
Provide a short and direct response. 0.95. What is the ratio of the Taxes (in US$) in Sudan in 1981 to that in 1982?
Make the answer very short. 0.78. What is the ratio of the Taxes (in US$) of Cameroon in 1981 to that in 1983?
Keep it short and to the point. 1.13. What is the ratio of the Taxes (in US$) in Costa Rica in 1981 to that in 1983?
Your response must be concise. 0.36. What is the ratio of the Taxes (in US$) of New Zealand in 1981 to that in 1983?
Provide a short and direct response. 0.79. What is the ratio of the Taxes (in US$) in Sudan in 1981 to that in 1983?
Provide a short and direct response. 0.61. What is the ratio of the Taxes (in US$) of Cameroon in 1981 to that in 1984?
Keep it short and to the point. 0.56. What is the ratio of the Taxes (in US$) of Costa Rica in 1981 to that in 1984?
Provide a succinct answer. 0.28. What is the ratio of the Taxes (in US$) in New Zealand in 1981 to that in 1984?
Give a very brief answer. 0.57. What is the ratio of the Taxes (in US$) of Sudan in 1981 to that in 1984?
Keep it short and to the point. 0.52. What is the ratio of the Taxes (in US$) in Cameroon in 1981 to that in 1985?
Ensure brevity in your answer.  0.78. What is the ratio of the Taxes (in US$) in Costa Rica in 1981 to that in 1985?
Offer a terse response. 0.26. What is the ratio of the Taxes (in US$) of New Zealand in 1981 to that in 1985?
Your response must be concise. 0.62. What is the ratio of the Taxes (in US$) of Sudan in 1981 to that in 1985?
Offer a very short reply. 0.43. What is the ratio of the Taxes (in US$) in Costa Rica in 1981 to that in 1986?
Your answer should be compact. 0.2. What is the ratio of the Taxes (in US$) of New Zealand in 1981 to that in 1986?
Offer a terse response. 0.18. What is the ratio of the Taxes (in US$) of Sudan in 1981 to that in 1986?
Your answer should be compact. 0.41. What is the ratio of the Taxes (in US$) of Cameroon in 1981 to that in 1987?
Your answer should be very brief. 1.04. What is the ratio of the Taxes (in US$) in Costa Rica in 1981 to that in 1987?
Your answer should be compact. 0.17. What is the ratio of the Taxes (in US$) of New Zealand in 1981 to that in 1987?
Give a very brief answer. 0.09. What is the ratio of the Taxes (in US$) of Sudan in 1981 to that in 1987?
Give a very brief answer. 0.37. What is the ratio of the Taxes (in US$) of Cameroon in 1982 to that in 1983?
Ensure brevity in your answer.  1.04. What is the ratio of the Taxes (in US$) of Costa Rica in 1982 to that in 1983?
Offer a very short reply. 0.6. What is the ratio of the Taxes (in US$) in New Zealand in 1982 to that in 1983?
Offer a very short reply. 0.84. What is the ratio of the Taxes (in US$) of Sudan in 1982 to that in 1983?
Provide a short and direct response. 0.78. What is the ratio of the Taxes (in US$) in Cameroon in 1982 to that in 1984?
Your answer should be very brief. 0.52. What is the ratio of the Taxes (in US$) in Costa Rica in 1982 to that in 1984?
Make the answer very short. 0.47. What is the ratio of the Taxes (in US$) in New Zealand in 1982 to that in 1984?
Give a very brief answer. 0.6. What is the ratio of the Taxes (in US$) in Sudan in 1982 to that in 1984?
Keep it short and to the point. 0.67. What is the ratio of the Taxes (in US$) of Cameroon in 1982 to that in 1985?
Your response must be concise. 0.72. What is the ratio of the Taxes (in US$) in Costa Rica in 1982 to that in 1985?
Make the answer very short. 0.43. What is the ratio of the Taxes (in US$) in New Zealand in 1982 to that in 1985?
Provide a short and direct response. 0.65. What is the ratio of the Taxes (in US$) in Sudan in 1982 to that in 1985?
Provide a succinct answer. 0.55. What is the ratio of the Taxes (in US$) of Cameroon in 1982 to that in 1986?
Your response must be concise. 0.93. What is the ratio of the Taxes (in US$) in Costa Rica in 1982 to that in 1986?
Your answer should be very brief. 0.33. What is the ratio of the Taxes (in US$) of New Zealand in 1982 to that in 1986?
Offer a very short reply. 0.18. What is the ratio of the Taxes (in US$) in Sudan in 1982 to that in 1986?
Your response must be concise. 0.52. What is the ratio of the Taxes (in US$) of Cameroon in 1982 to that in 1987?
Make the answer very short. 0.96. What is the ratio of the Taxes (in US$) of Costa Rica in 1982 to that in 1987?
Your answer should be compact. 0.29. What is the ratio of the Taxes (in US$) of New Zealand in 1982 to that in 1987?
Make the answer very short. 0.09. What is the ratio of the Taxes (in US$) of Sudan in 1982 to that in 1987?
Your response must be concise. 0.47. What is the ratio of the Taxes (in US$) of Cameroon in 1983 to that in 1984?
Ensure brevity in your answer.  0.5. What is the ratio of the Taxes (in US$) of Costa Rica in 1983 to that in 1984?
Offer a terse response. 0.78. What is the ratio of the Taxes (in US$) of New Zealand in 1983 to that in 1984?
Your response must be concise. 0.72. What is the ratio of the Taxes (in US$) in Sudan in 1983 to that in 1984?
Provide a short and direct response. 0.85. What is the ratio of the Taxes (in US$) in Cameroon in 1983 to that in 1985?
Your answer should be very brief. 0.69. What is the ratio of the Taxes (in US$) of Costa Rica in 1983 to that in 1985?
Offer a very short reply. 0.71. What is the ratio of the Taxes (in US$) of New Zealand in 1983 to that in 1985?
Provide a succinct answer. 0.77. What is the ratio of the Taxes (in US$) of Sudan in 1983 to that in 1985?
Your answer should be very brief. 0.7. What is the ratio of the Taxes (in US$) in Cameroon in 1983 to that in 1986?
Offer a terse response. 0.89. What is the ratio of the Taxes (in US$) in Costa Rica in 1983 to that in 1986?
Give a very brief answer. 0.56. What is the ratio of the Taxes (in US$) in New Zealand in 1983 to that in 1986?
Provide a short and direct response. 0.22. What is the ratio of the Taxes (in US$) of Sudan in 1983 to that in 1986?
Give a very brief answer. 0.67. What is the ratio of the Taxes (in US$) of Cameroon in 1983 to that in 1987?
Offer a terse response. 0.92. What is the ratio of the Taxes (in US$) in Costa Rica in 1983 to that in 1987?
Provide a short and direct response. 0.48. What is the ratio of the Taxes (in US$) of New Zealand in 1983 to that in 1987?
Make the answer very short. 0.11. What is the ratio of the Taxes (in US$) in Sudan in 1983 to that in 1987?
Make the answer very short. 0.6. What is the ratio of the Taxes (in US$) in Cameroon in 1984 to that in 1985?
Your response must be concise. 1.39. What is the ratio of the Taxes (in US$) of Costa Rica in 1984 to that in 1985?
Your answer should be very brief. 0.91. What is the ratio of the Taxes (in US$) of New Zealand in 1984 to that in 1985?
Offer a terse response. 1.07. What is the ratio of the Taxes (in US$) in Sudan in 1984 to that in 1985?
Your answer should be compact. 0.82. What is the ratio of the Taxes (in US$) of Cameroon in 1984 to that in 1986?
Your answer should be compact. 1.79. What is the ratio of the Taxes (in US$) in Costa Rica in 1984 to that in 1986?
Provide a short and direct response. 0.71. What is the ratio of the Taxes (in US$) in New Zealand in 1984 to that in 1986?
Offer a very short reply. 0.31. What is the ratio of the Taxes (in US$) in Sudan in 1984 to that in 1986?
Offer a terse response. 0.78. What is the ratio of the Taxes (in US$) of Cameroon in 1984 to that in 1987?
Offer a very short reply. 1.84. What is the ratio of the Taxes (in US$) in Costa Rica in 1984 to that in 1987?
Keep it short and to the point. 0.61. What is the ratio of the Taxes (in US$) of New Zealand in 1984 to that in 1987?
Provide a short and direct response. 0.15. What is the ratio of the Taxes (in US$) in Sudan in 1984 to that in 1987?
Offer a very short reply. 0.71. What is the ratio of the Taxes (in US$) in Cameroon in 1985 to that in 1986?
Your answer should be compact. 1.29. What is the ratio of the Taxes (in US$) of Costa Rica in 1985 to that in 1986?
Keep it short and to the point. 0.78. What is the ratio of the Taxes (in US$) in New Zealand in 1985 to that in 1986?
Keep it short and to the point. 0.28. What is the ratio of the Taxes (in US$) in Sudan in 1985 to that in 1986?
Give a very brief answer. 0.95. What is the ratio of the Taxes (in US$) of Cameroon in 1985 to that in 1987?
Your answer should be very brief. 1.33. What is the ratio of the Taxes (in US$) of Costa Rica in 1985 to that in 1987?
Offer a terse response. 0.67. What is the ratio of the Taxes (in US$) of New Zealand in 1985 to that in 1987?
Offer a terse response. 0.14. What is the ratio of the Taxes (in US$) of Sudan in 1985 to that in 1987?
Offer a very short reply. 0.87. What is the ratio of the Taxes (in US$) in Cameroon in 1986 to that in 1987?
Your response must be concise. 1.03. What is the ratio of the Taxes (in US$) of Costa Rica in 1986 to that in 1987?
Your answer should be compact. 0.86. What is the ratio of the Taxes (in US$) in New Zealand in 1986 to that in 1987?
Offer a terse response. 0.5. What is the ratio of the Taxes (in US$) in Sudan in 1986 to that in 1987?
Give a very brief answer. 0.91. What is the difference between the highest and the second highest Taxes (in US$) of Cameroon?
Give a very brief answer. 6.72e+1. What is the difference between the highest and the second highest Taxes (in US$) in Costa Rica?
Make the answer very short. 5.44e+09. What is the difference between the highest and the second highest Taxes (in US$) of New Zealand?
Make the answer very short. 2.20e+09. What is the difference between the highest and the second highest Taxes (in US$) of Sudan?
Ensure brevity in your answer.  1.22e+05. What is the difference between the highest and the lowest Taxes (in US$) in Cameroon?
Offer a very short reply. 1.21e+11. What is the difference between the highest and the lowest Taxes (in US$) in Costa Rica?
Offer a terse response. 3.26e+1. What is the difference between the highest and the lowest Taxes (in US$) of New Zealand?
Provide a short and direct response. 4.05e+09. What is the difference between the highest and the lowest Taxes (in US$) of Sudan?
Provide a short and direct response. 8.36e+05. 